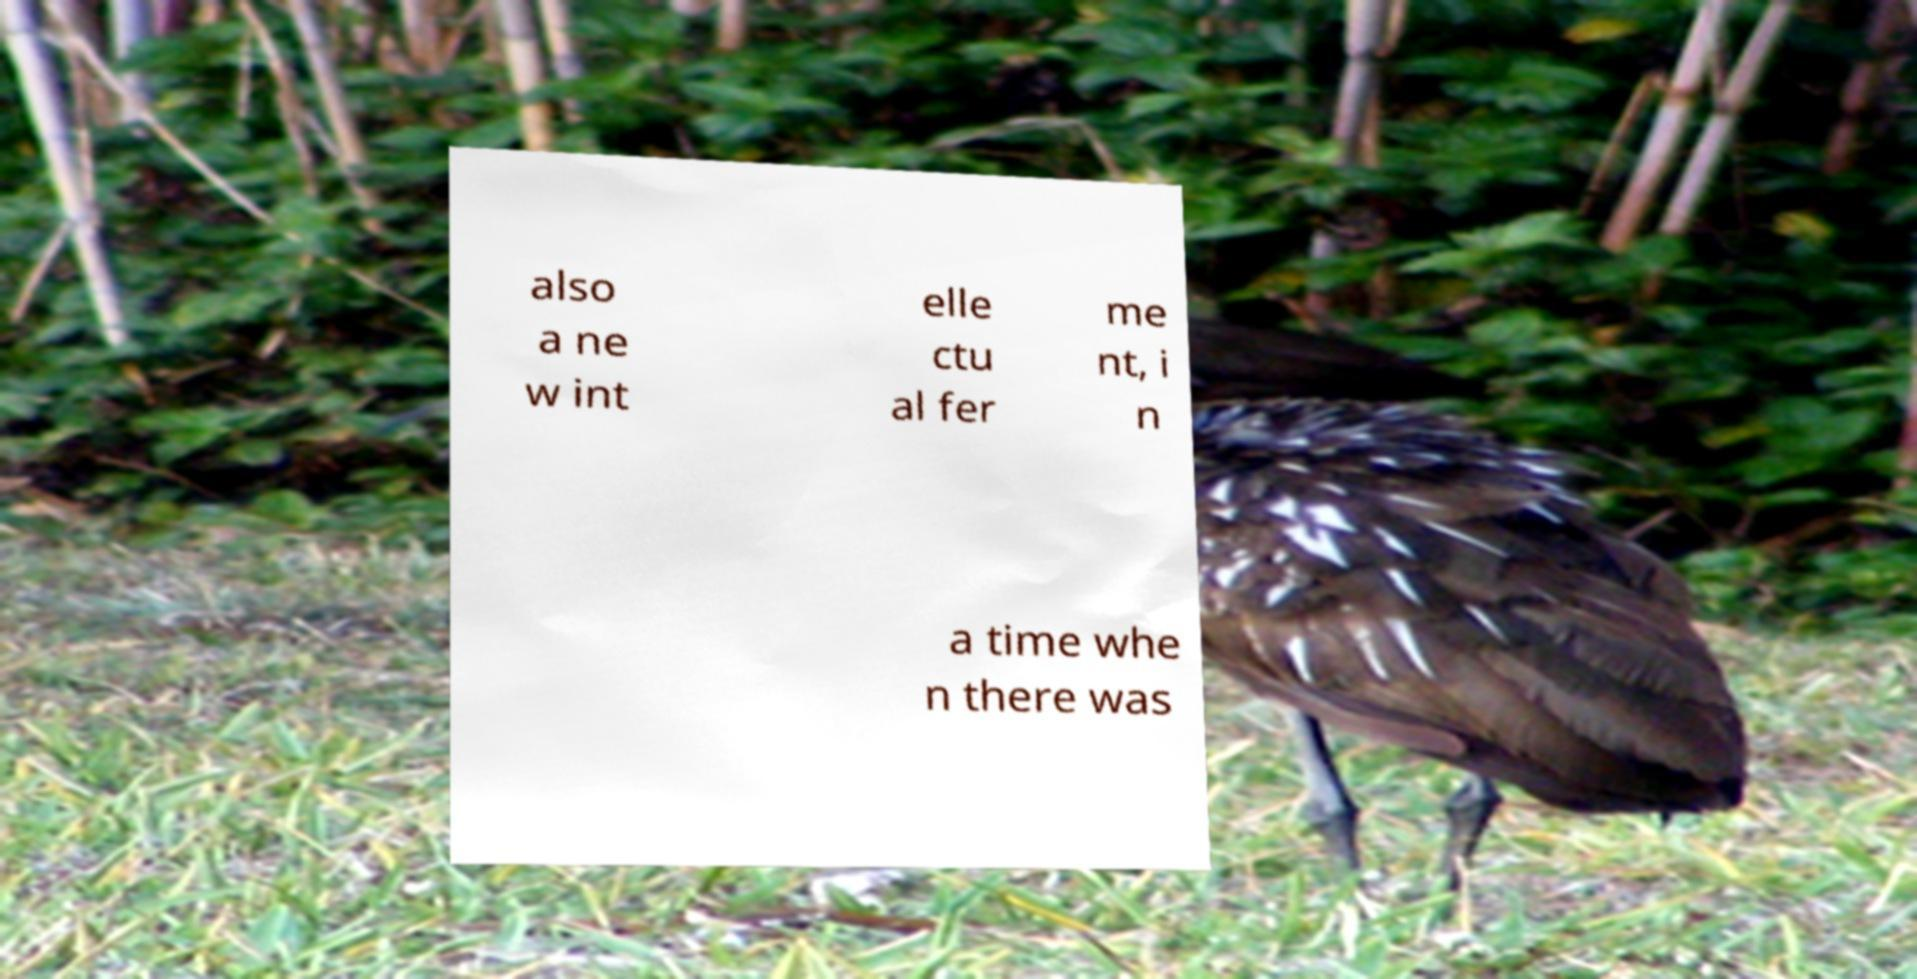Could you extract and type out the text from this image? also a ne w int elle ctu al fer me nt, i n a time whe n there was 